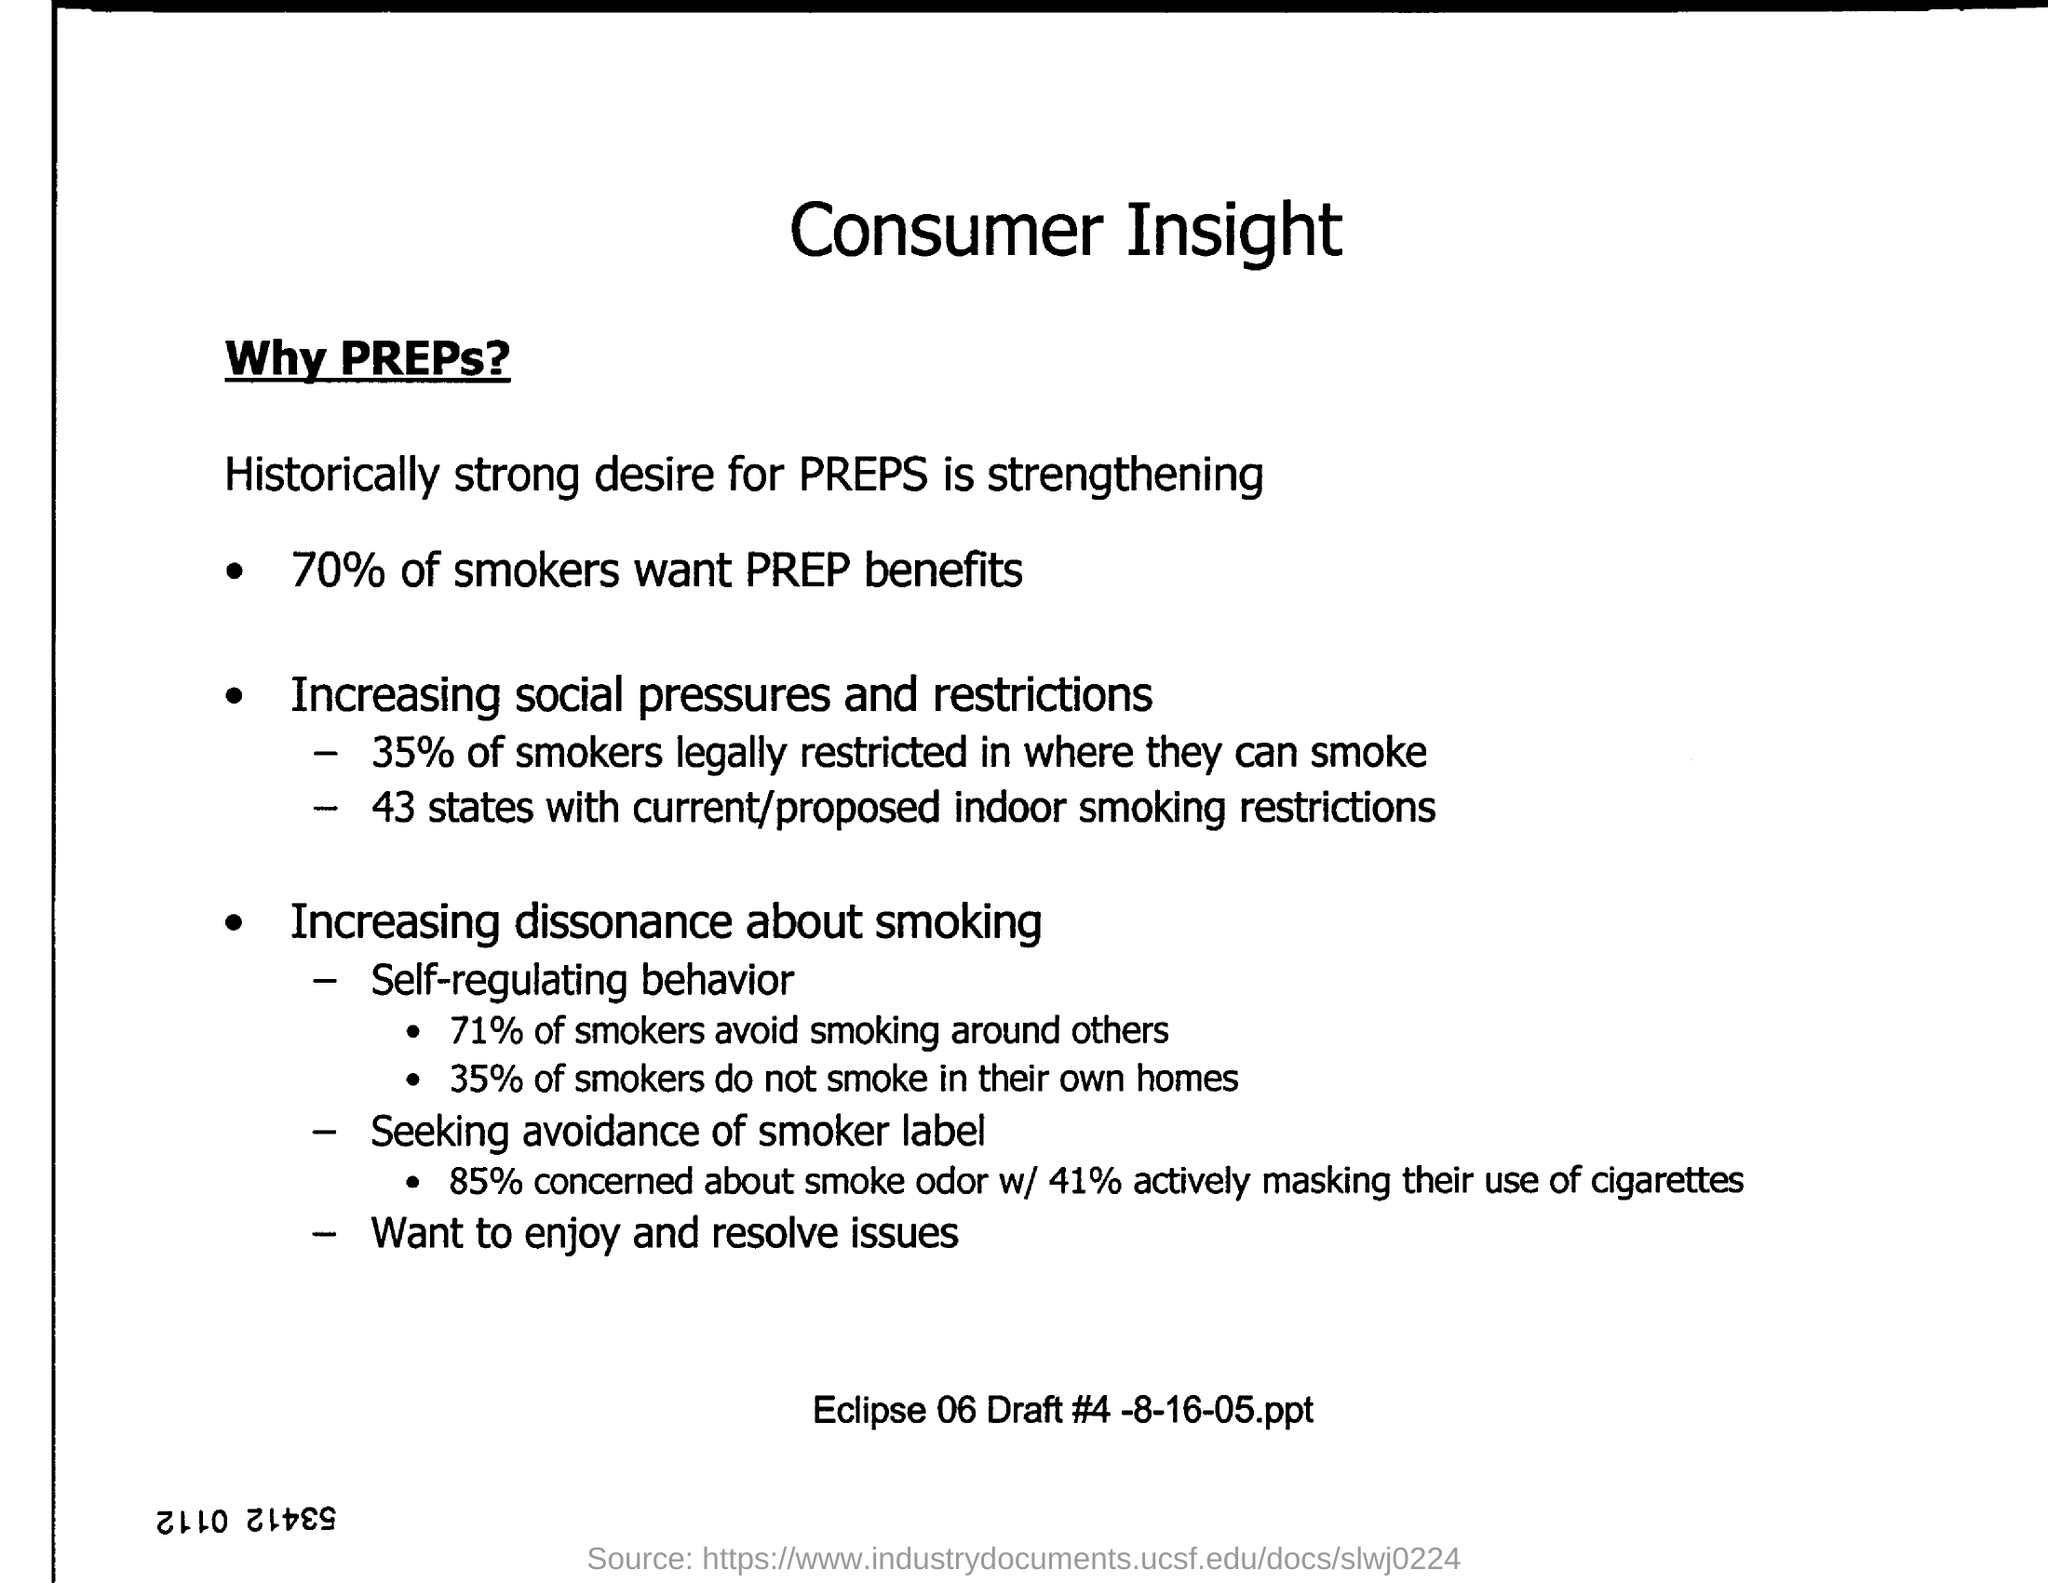How many states have current/proposed indoor smoking restrictions? According to the information available in the provided image, there are 43 states with current or proposed regulations on indoor smoking. These restrictions reflect the growing trend of implementing measures to protect the public from secondhand smoke and to create healthier environments in indoor spaces. 